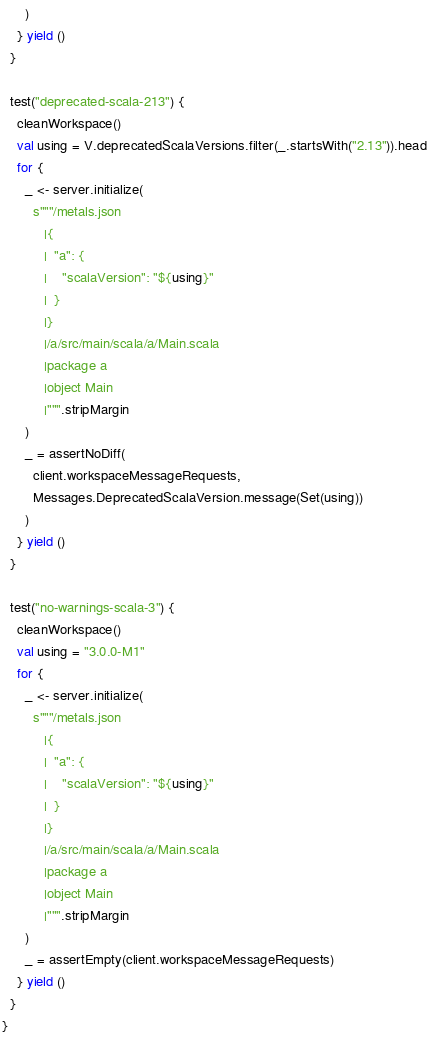Convert code to text. <code><loc_0><loc_0><loc_500><loc_500><_Scala_>      )
    } yield ()
  }

  test("deprecated-scala-213") {
    cleanWorkspace()
    val using = V.deprecatedScalaVersions.filter(_.startsWith("2.13")).head
    for {
      _ <- server.initialize(
        s"""/metals.json
           |{
           |  "a": {
           |    "scalaVersion": "${using}"
           |  }
           |}
           |/a/src/main/scala/a/Main.scala
           |package a
           |object Main
           |""".stripMargin
      )
      _ = assertNoDiff(
        client.workspaceMessageRequests,
        Messages.DeprecatedScalaVersion.message(Set(using))
      )
    } yield ()
  }

  test("no-warnings-scala-3") {
    cleanWorkspace()
    val using = "3.0.0-M1"
    for {
      _ <- server.initialize(
        s"""/metals.json
           |{
           |  "a": {
           |    "scalaVersion": "${using}"
           |  }
           |}
           |/a/src/main/scala/a/Main.scala
           |package a
           |object Main
           |""".stripMargin
      )
      _ = assertEmpty(client.workspaceMessageRequests)
    } yield ()
  }
}
</code> 